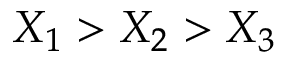Convert formula to latex. <formula><loc_0><loc_0><loc_500><loc_500>X _ { 1 } > X _ { 2 } > X _ { 3 }</formula> 